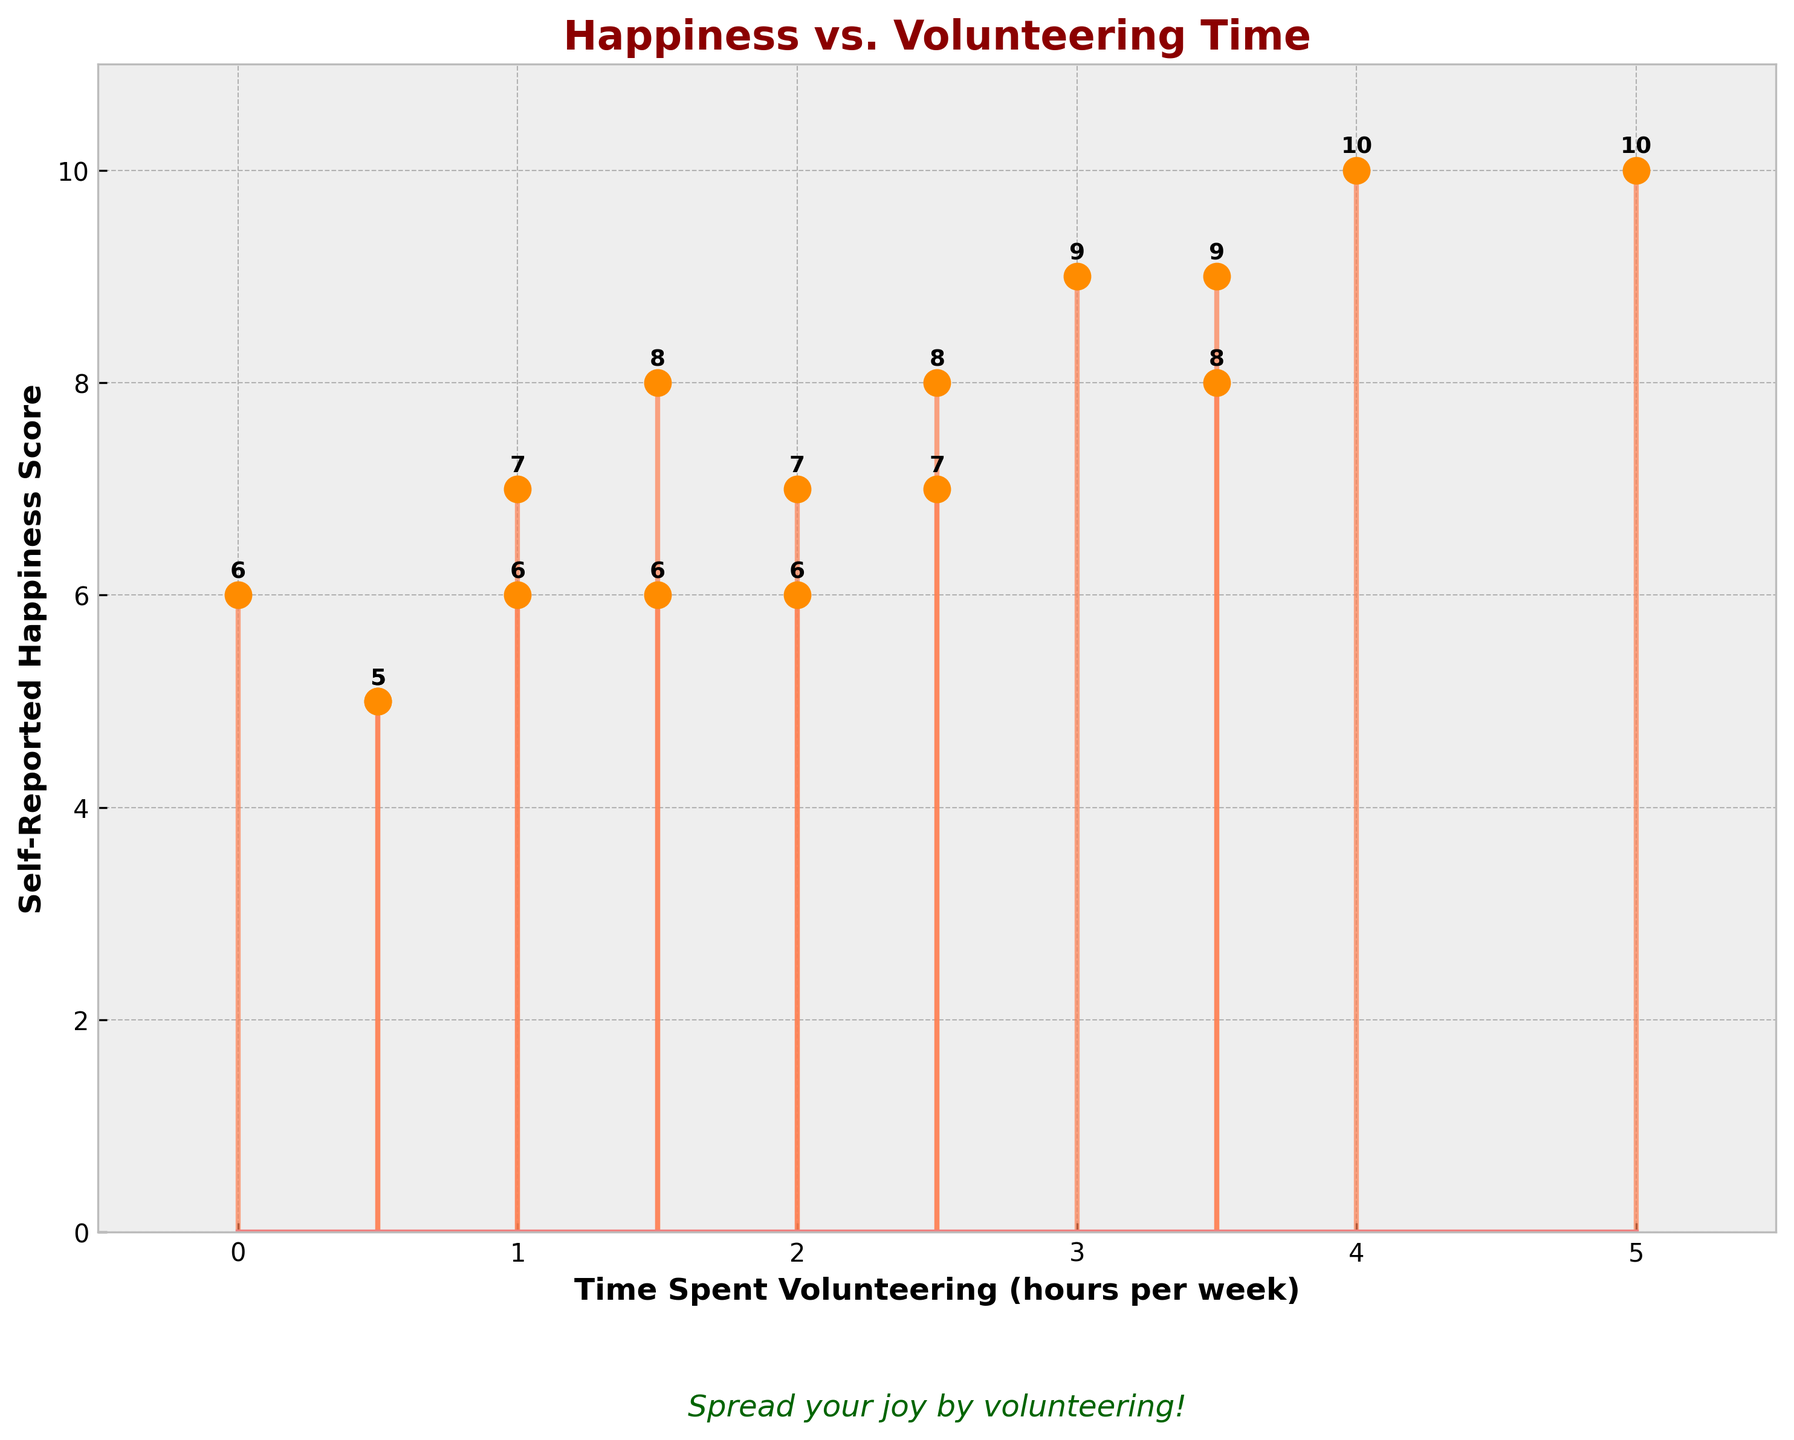What is the title of the figure? The title is written at the top of the figure in bold and colored dark red.
Answer: Happiness vs. Volunteering Time How many hours per week of volunteering corresponds to a happiness score of 10? By looking at the points where the happiness score is 10, there are scores at 4 hours and 5 hours of volunteering per week.
Answer: 4 and 5 What is the range of the self-reported happiness scores in the figure? The minimum happiness score is 5, and the maximum is 10. The range is calculated by subtracting 5 from 10.
Answer: 5 Is there a general trend between happiness scores and time spent volunteering? Observing the figure, happiness scores generally increase with more time spent volunteering, with few exceptions.
Answer: Yes How much time is spent volunteering by the person with a happiness score of 9? By finding the points on the plot where the happiness score is 9, we see it corresponds to 3 hours and 3.5 hours per week.
Answer: 3 and 3.5 What is the median time spent volunteering? When listed in ascending order, we have 0, 0.5, 0.5, 1, 1, 1.5, 1.5, 2, 2.5, 2.5, 3, 3.5, 3.5, 4, 5. The median is the average of the 8th and 9th values.
Answer: 2.25 Which happiness score has the most data points and how many? From visual inspection, the happiness scores of 6 and 7 each appear three times, which is the highest frequency.
Answer: 6 and 7 (three times each) Is there an annotation or extra text on the figure, and if so, what does it say? At the bottom of the plot, a text in italicized dark green reads "Spread your joy by volunteering!"
Answer: Spread your joy by volunteering! What is the average happiness score for those who volunteer 2 hours per week or less? For these values: 7, 6, 8, 5, 6, 6, the sum is 38. Dividing by 6 gives an average of approximately 6.33.
Answer: 6.33 What colors are used for the markers and the baseline in the figure? The marker is dark orange, and the baseline is light coral.
Answer: Dark orange and light coral 